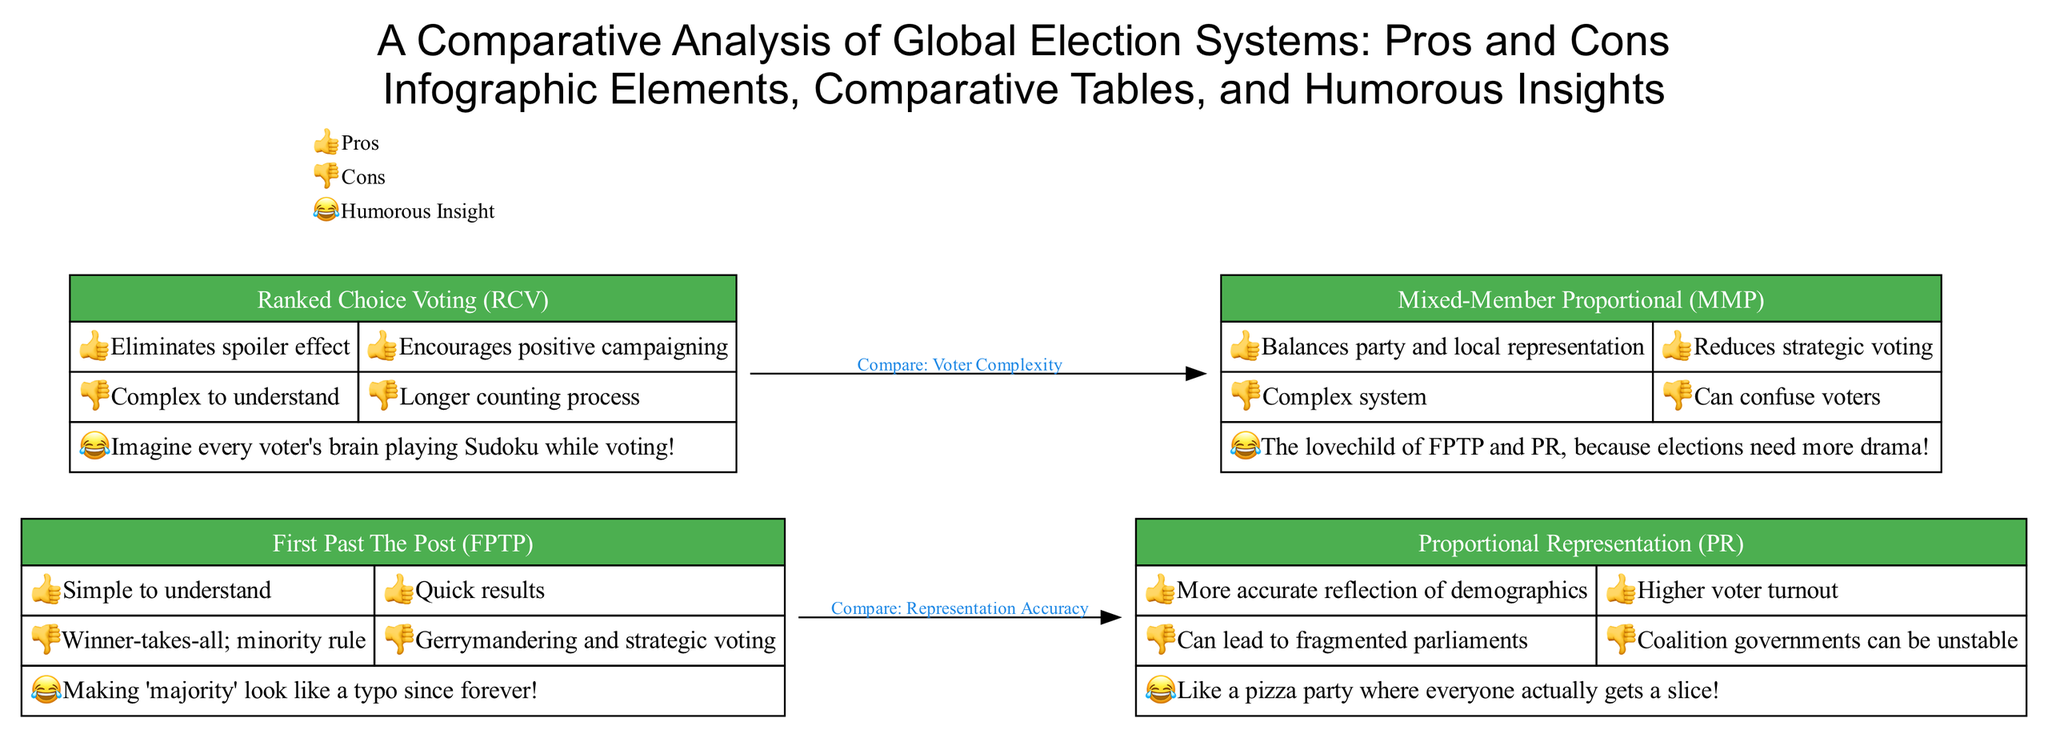What are the two pros of First Past The Post? The diagram lists two pros under the First Past The Post node: "Simple to understand" and "Quick results."
Answer: Simple to understand; Quick results What type of voting system encourages positive campaigning? The Ranked Choice Voting node mentions that it "Encourages positive campaigning" as one of its pros.
Answer: Ranked Choice Voting Which election system can lead to fragmented parliaments? Under the Proportional Representation node, it states that "Can lead to fragmented parliaments" as one of its cons.
Answer: Proportional Representation How many humorous insights are provided in total across the systems? The diagram has one humorous insight listed under each election system. Since there are four systems, that makes a total of four humorous insights.
Answer: Four What is the relationship between Ranked Choice Voting and Mixed-Member Proportional? The edge labeled "Compare: Voter Complexity" connects the Ranked Choice Voting node to the Mixed-Member Proportional node, indicating a comparison between these two systems in terms of complexity.
Answer: Compare: Voter Complexity What humor is associated with Mixed-Member Proportional? The diagram lists the humorous insight associated with Mixed-Member Proportional as: "The lovechild of FPTP and PR, because elections need more drama!"
Answer: The lovechild of FPTP and PR, because elections need more drama! Which voting system has a quick counting process as a pro? The First Past The Post system indicates it has a "Quick results" pro, implying simplicity in the counting process.
Answer: First Past The Post What is the main con of Ranked Choice Voting regarding its complexity? The Ranked Choice Voting node states that it is "Complex to understand," which is its main con regarding user experience and operational complexity.
Answer: Complex to understand What does '👍' symbolize in the diagram? The legend at the bottom shows that '👍' symbolizes "Pros," indicating the positive aspects of each election system.
Answer: Pros 